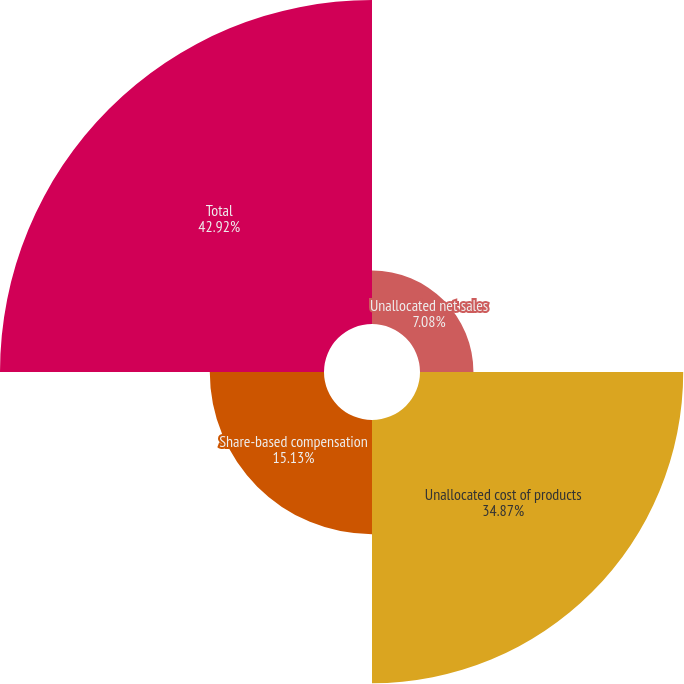Convert chart. <chart><loc_0><loc_0><loc_500><loc_500><pie_chart><fcel>Unallocated net sales<fcel>Unallocated cost of products<fcel>Share-based compensation<fcel>Total<nl><fcel>7.08%<fcel>34.87%<fcel>15.13%<fcel>42.92%<nl></chart> 